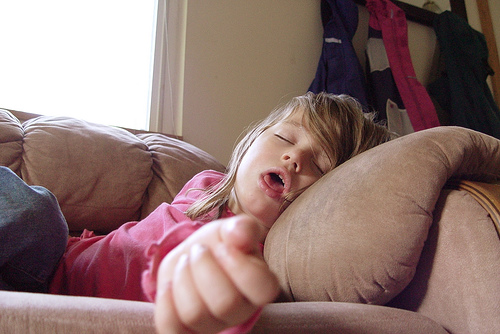<image>
Is the coat to the right of the girl? No. The coat is not to the right of the girl. The horizontal positioning shows a different relationship. 